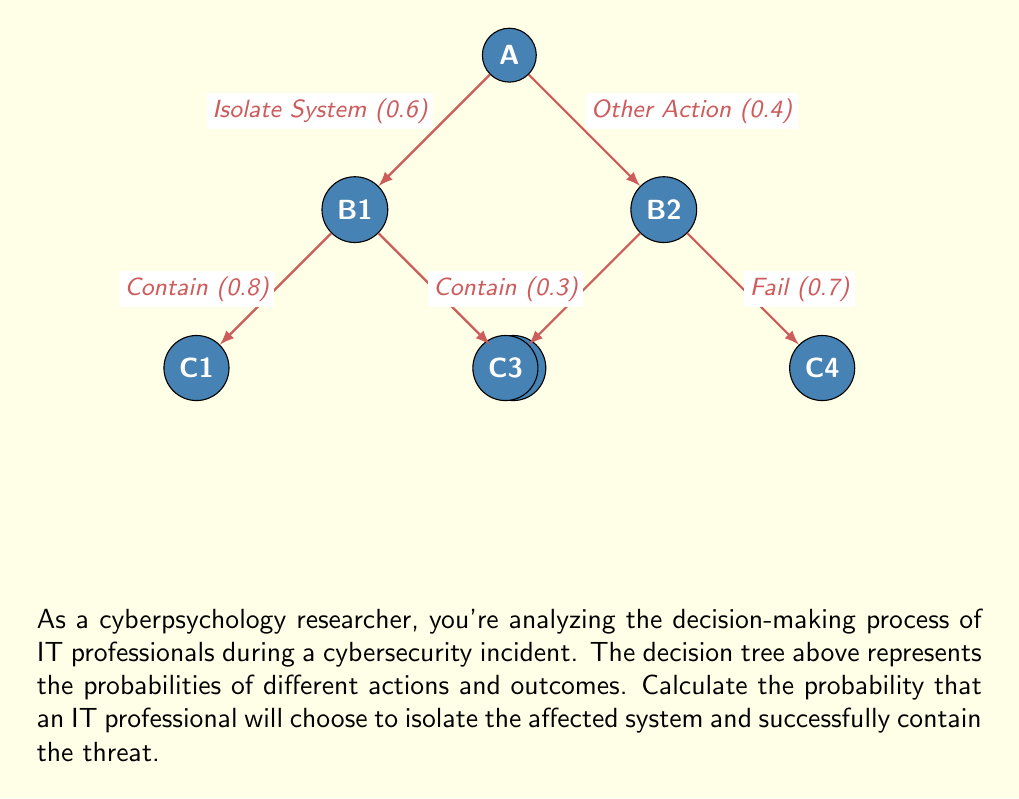Teach me how to tackle this problem. To solve this problem, we need to follow these steps:

1) Identify the path that represents choosing to isolate the system and successfully containing the threat. This is the path A → B1 → C1.

2) Calculate the probability of this path by multiplying the probabilities along the path:

   $P(\text{Isolate and Contain}) = P(\text{Isolate}) \times P(\text{Contain | Isolate})$

3) From the decision tree:
   - The probability of choosing to isolate the system is 0.6
   - Given that the system is isolated, the probability of containing the threat is 0.8

4) Therefore:

   $P(\text{Isolate and Contain}) = 0.6 \times 0.8 = 0.48$

Thus, the probability that an IT professional will choose to isolate the affected system and successfully contain the threat is 0.48 or 48%.
Answer: $0.48$ 